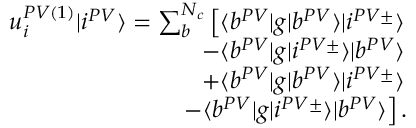<formula> <loc_0><loc_0><loc_500><loc_500>\begin{array} { r } { u _ { i } ^ { P V ( 1 ) } | i ^ { P V } \rangle = \sum _ { b } ^ { N _ { c } } \left [ \langle b ^ { P V } | g | b ^ { P V } \rangle | i ^ { P V \pm } \rangle } \\ { - \langle b ^ { P V } | g | i ^ { P V \pm } \rangle | b ^ { P V } \rangle } \\ { + \langle b ^ { P V } | g | b ^ { P V } \rangle | i ^ { P V \pm } \rangle } \\ { - \langle b ^ { P V } | g | i ^ { P V \pm } \rangle | b ^ { P V } \rangle \right ] . } \end{array}</formula> 